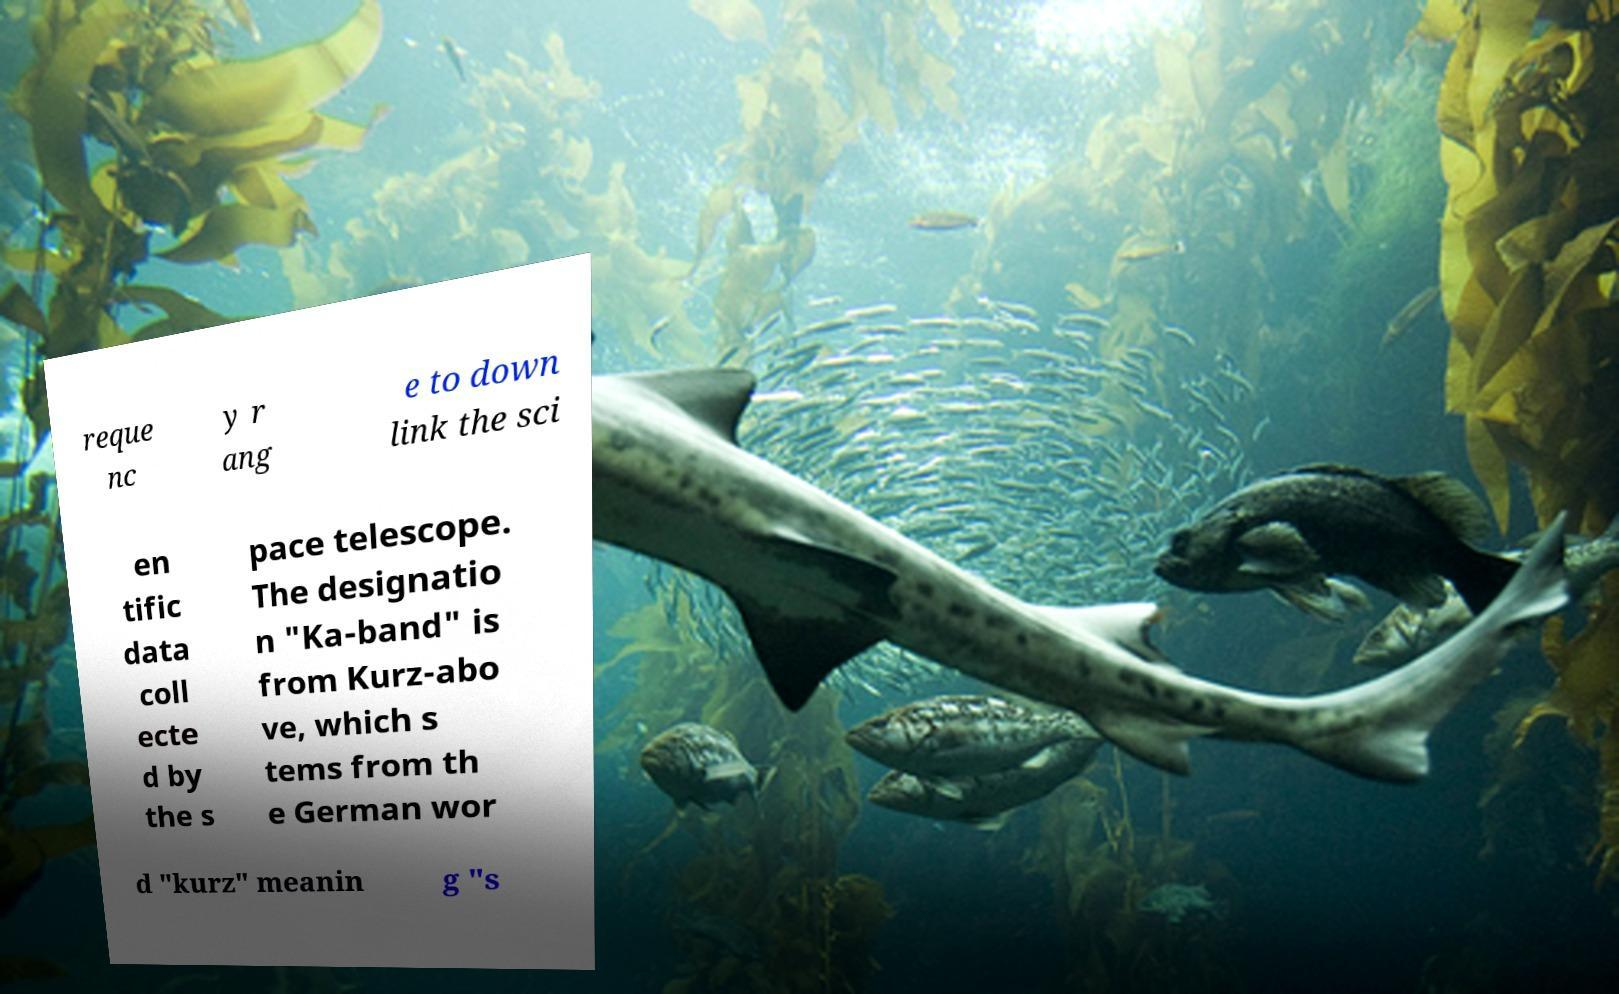Can you accurately transcribe the text from the provided image for me? reque nc y r ang e to down link the sci en tific data coll ecte d by the s pace telescope. The designatio n "Ka-band" is from Kurz-abo ve, which s tems from th e German wor d "kurz" meanin g "s 